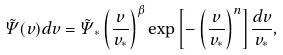Convert formula to latex. <formula><loc_0><loc_0><loc_500><loc_500>\tilde { \Psi } ( v ) d v = \tilde { \Psi } _ { * } \left ( \frac { v } { v _ { * } } \right ) ^ { \beta } \exp { \left [ - \left ( \frac { v } { v _ { * } } \right ) ^ { n } \right ] } \frac { d v } { v _ { * } } ,</formula> 